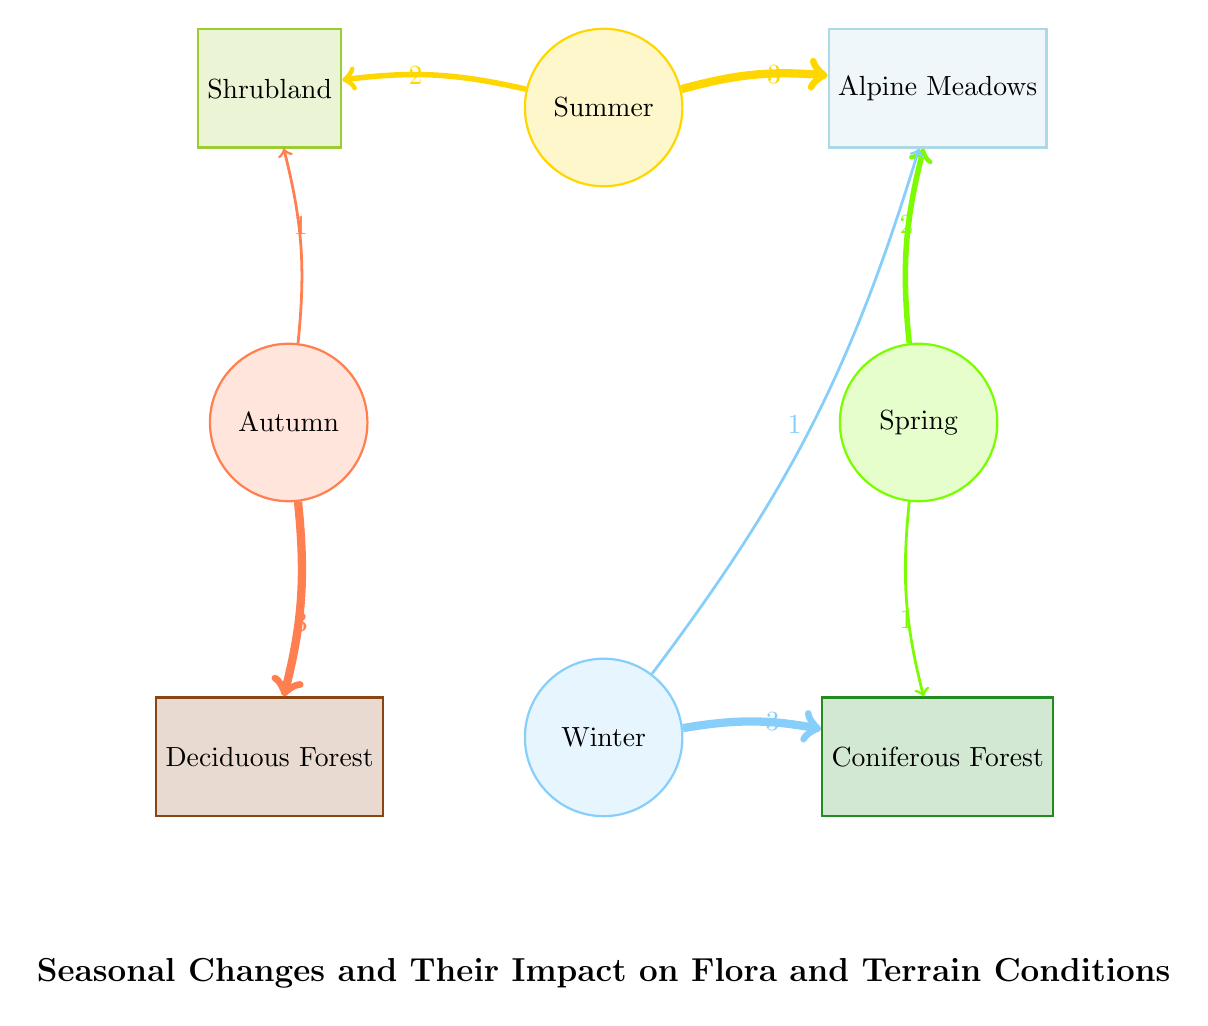What season has the highest influence on Alpine Meadows? The diagram shows that Summer has the highest link value to Alpine Meadows with a value of 3, which is greater than any other seasons.
Answer: Summer How many nodes are represented in the diagram? The diagram displays a total of eight nodes: four seasons and four types of flora/terrain. Counting these nodes confirms that there are indeed eight.
Answer: 8 Which season affects Deciduous Forest the most? The diagram indicates that Autumn has the highest influence on Deciduous Forest with a value of 3.
Answer: Autumn How many connections are there from Winter to other nodes? Analyzing the diagram shows that Winter connects to two nodes: Coniferous Forest with a value of 3 and Alpine Meadows with a value of 1, leading to a total of two connections.
Answer: 2 Which season has the lowest connection value to Coniferous Forest? From the diagram, Spring connects to Coniferous Forest with the value of 1, while Winter connects with a value of 3. Thus, Spring has the lowest connection value.
Answer: Spring What is the total influence on Shrubland from all seasons combined? By summing the connections from Summer (2) and Autumn (1), the total influence on Shrubland from all seasons amounts to 2 + 1 = 3.
Answer: 3 Which flora type is unaffected by Spring? The diagram reveals that Spring has no direct influence on Deciduous Forest, as it does not connect to it at all.
Answer: Deciduous Forest What is the relationship between Summer and Alpine Meadows? Summer has a strong connection to Alpine Meadows as indicated by a value of 3, showing significant influence in the diagram.
Answer: 3 